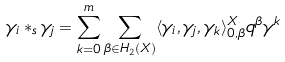Convert formula to latex. <formula><loc_0><loc_0><loc_500><loc_500>\gamma _ { i } * _ { s } \gamma _ { j } = \sum _ { k = 0 } ^ { m } \sum _ { \beta \in H _ { 2 } ( X ) } \langle \gamma _ { i } , \gamma _ { j } , \gamma _ { k } \rangle _ { 0 , \beta } ^ { X } q ^ { \beta } \gamma ^ { k }</formula> 